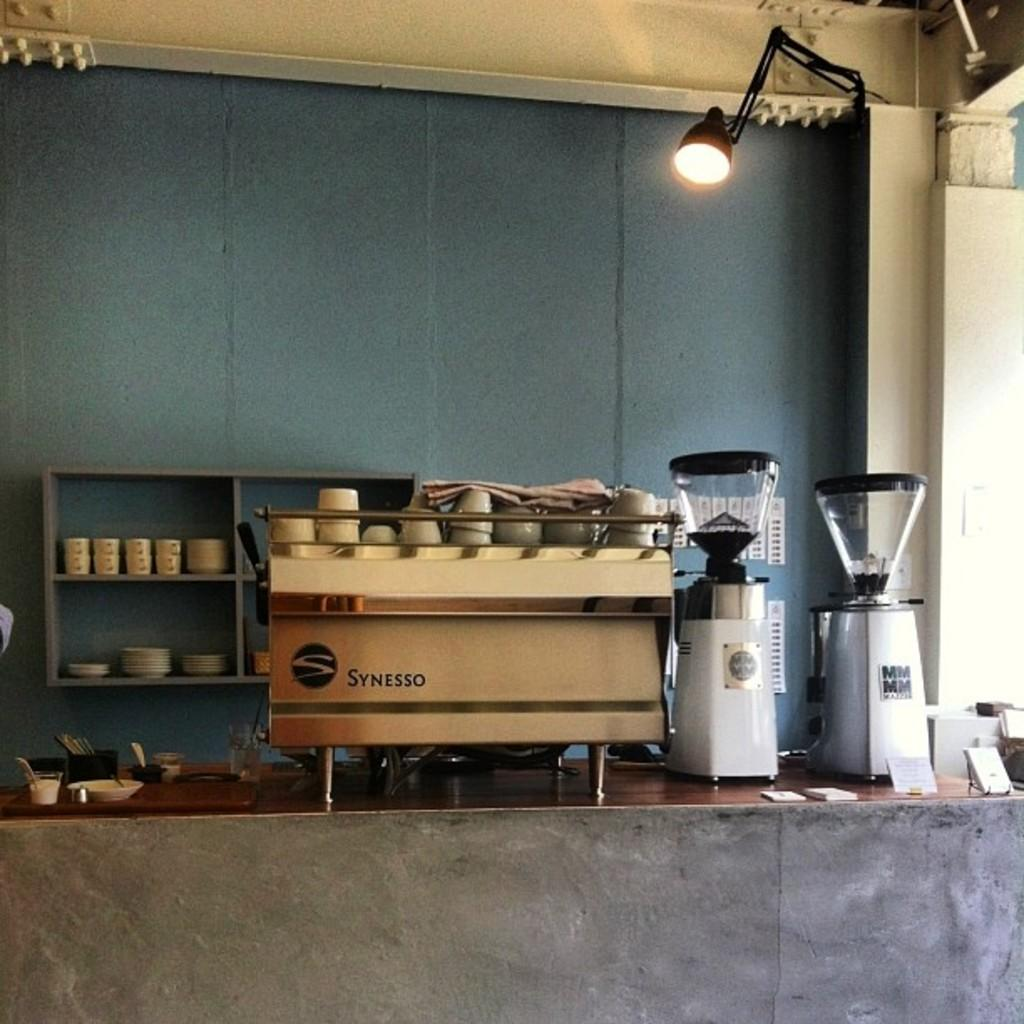<image>
Provide a brief description of the given image. A counter has a Synesso appliance on it. 